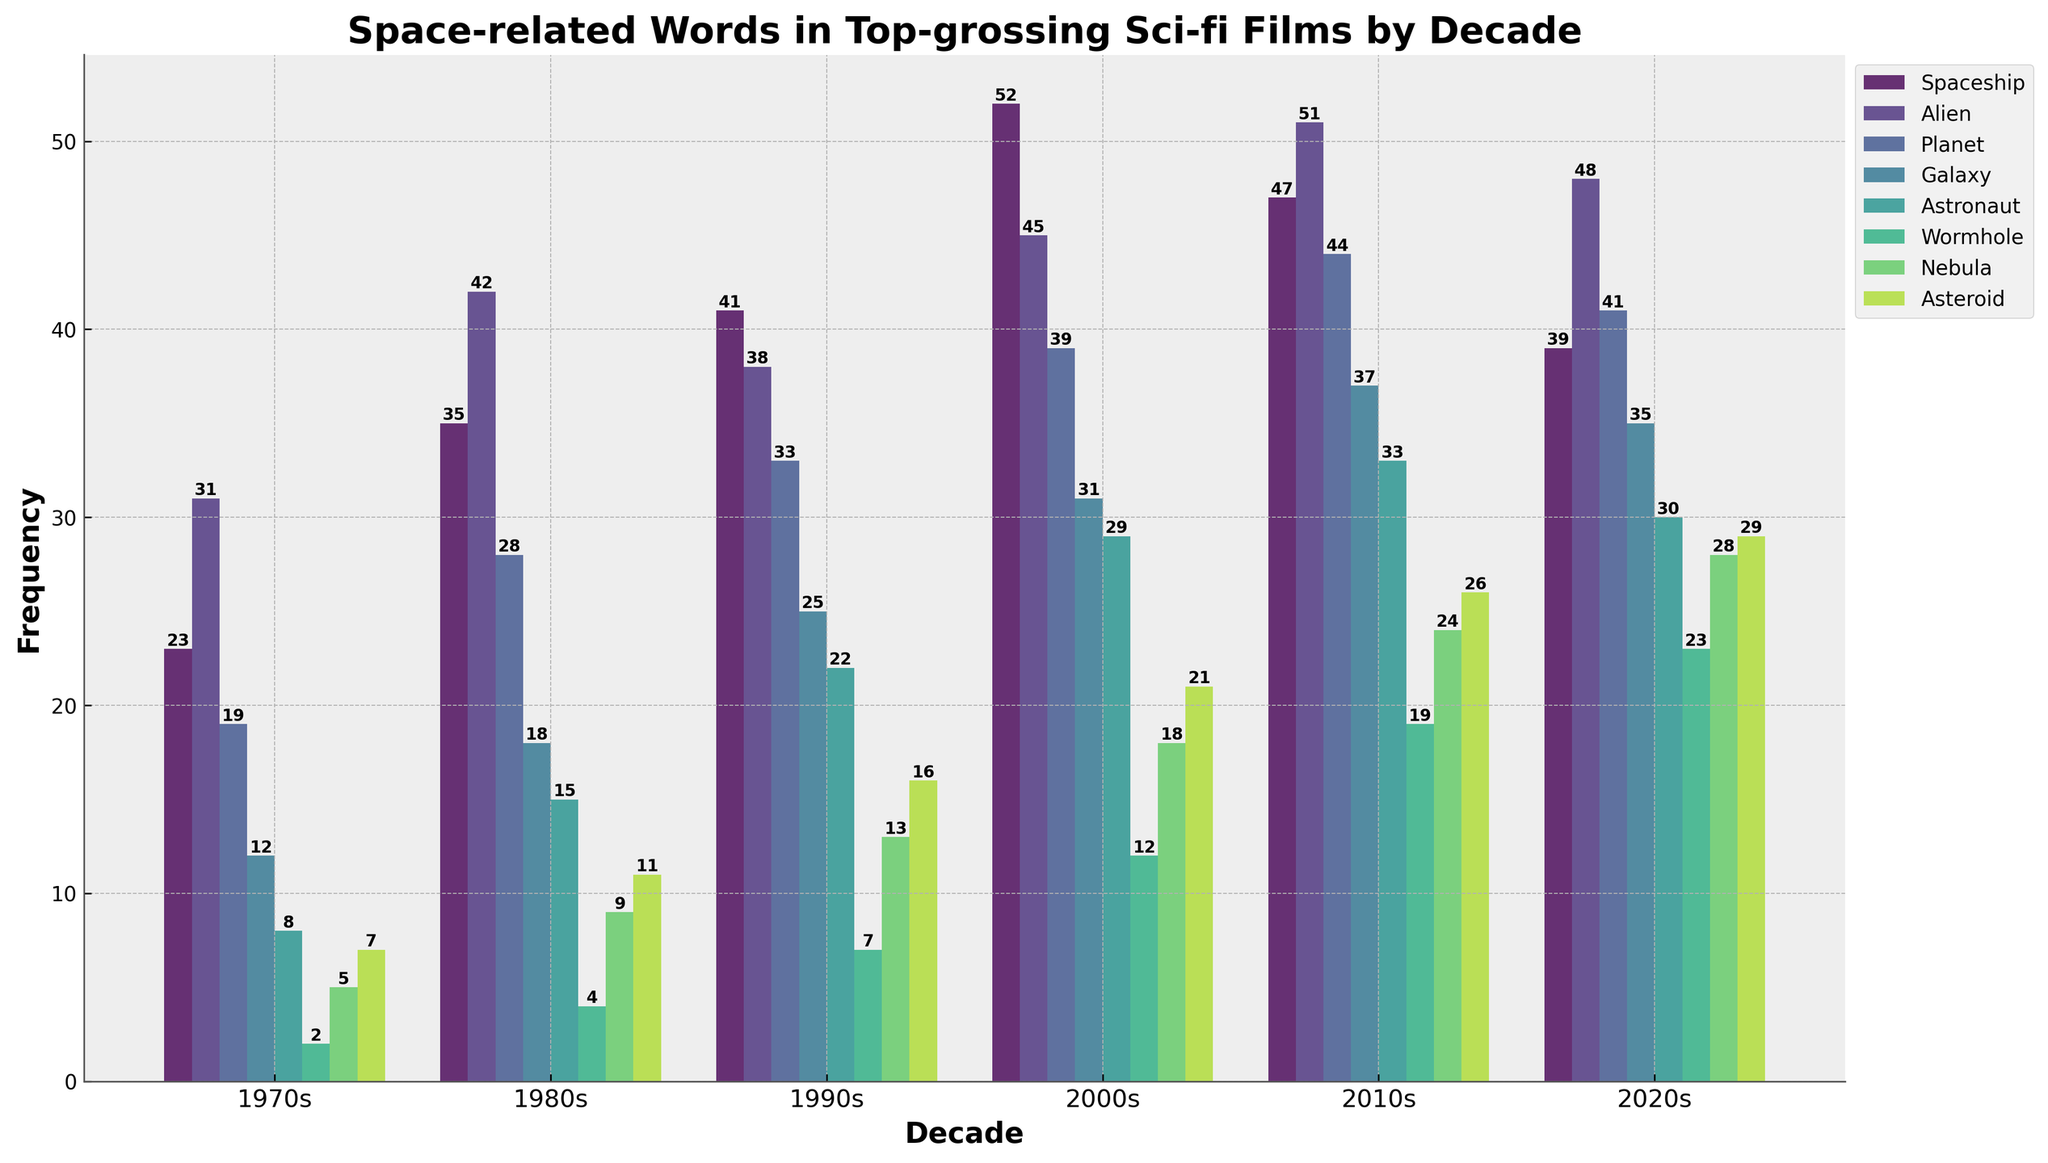Which decade used the word "Spaceship" the most frequently? Look at the height of the bars labeled "Spaceship" for different decades. The highest bar is in the 2000s.
Answer: 2000s Which word in the 1980s has the highest frequency? Among the bars for the 1980s, the highest is for the word "Alien."
Answer: Alien Comparing "Astronaut" and "Galaxy" in the 2010s, which word was used more frequently? Look at the bars for "Astronaut" and "Galaxy" in the 2010s. The bar for "Galaxy" is higher.
Answer: Galaxy What is the difference in frequency of the word "Wormhole" between the 2020s and 2000s? Subtract the frequency of "Wormhole" in the 2000s (12) from that in the 2020s (23).
Answer: 11 What is the average frequency of the words "Nebula" and "Asteroid" in the 2010s? Add the values for "Nebula" (24) and "Asteroid" (26) and divide by 2: (24 + 26) / 2 = 25.
Answer: 25 Which decade saw the largest increase in the use of the word "Planet" compared to the previous decade? Calculate the differences between consecutive decades for "Planet" and compare them. The largest difference is from the 1980s (28) to the 1990s (33), an increase of 5.
Answer: 1990s How many times was the word "Nebula" used in the 2000s? Look at the height of the bar for "Nebula" in the 2000s, which shows the value 18.
Answer: 18 By what percentage did the frequency of the word "Astronaut" increase from the 1990s to the 2010s? Calculate the difference: 33 - 22 = 11. Then, divide the difference by the 1990s value (22) and multiply by 100: (11 / 22) * 100 ≈ 50%.
Answer: 50% Which word's frequency remained consistently low across all decades? Compare the heights of all the bars across decades; "Wormhole" has consistently low values across all decades.
Answer: Wormhole 